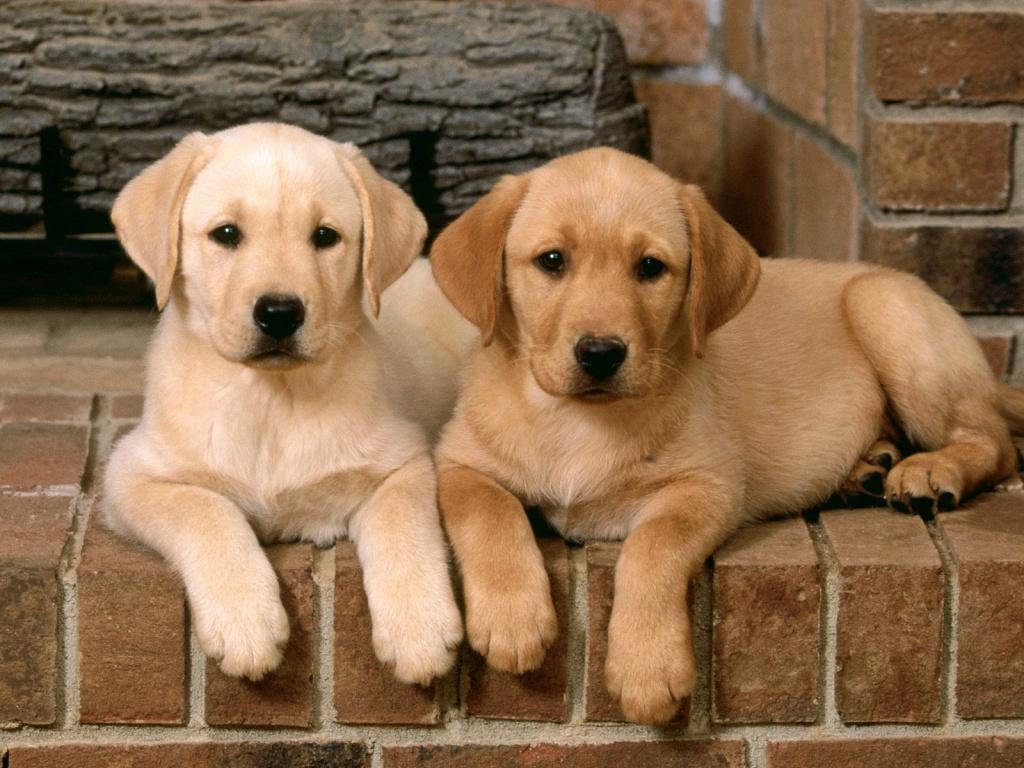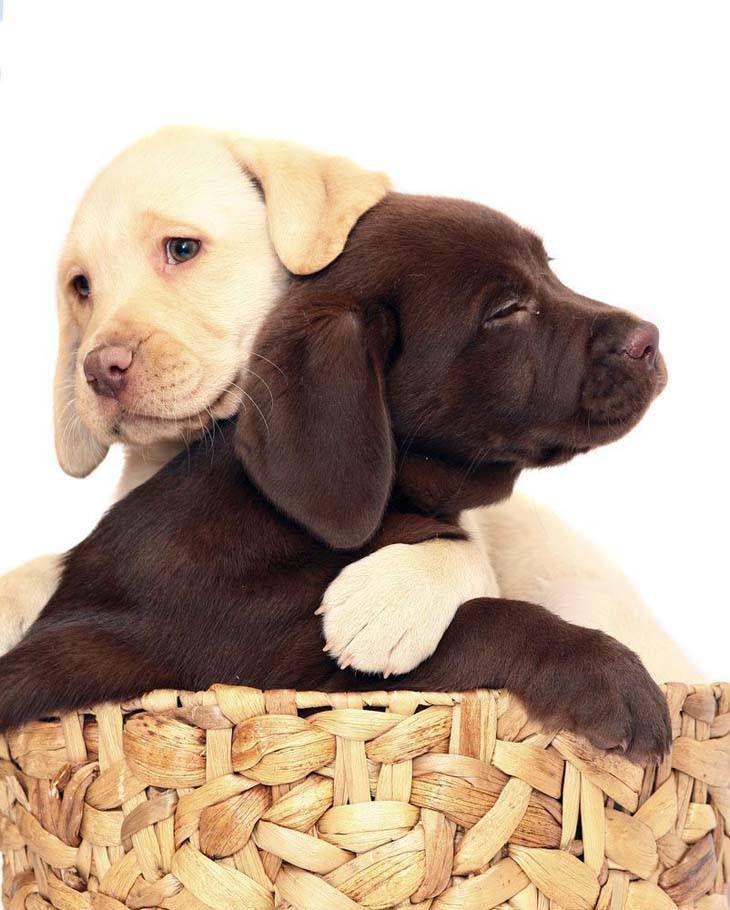The first image is the image on the left, the second image is the image on the right. For the images shown, is this caption "Two dogs are lying down in the image on the left." true? Answer yes or no. Yes. The first image is the image on the left, the second image is the image on the right. Analyze the images presented: Is the assertion "A puppy has a paw around a dark brownish-gray puppy that is reclining." valid? Answer yes or no. Yes. 